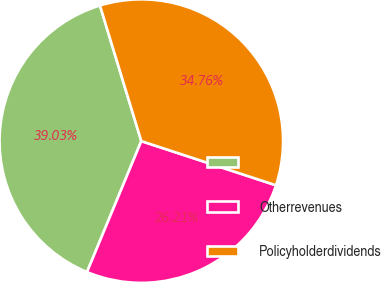<chart> <loc_0><loc_0><loc_500><loc_500><pie_chart><ecel><fcel>Otherrevenues<fcel>Policyholderdividends<nl><fcel>39.03%<fcel>26.21%<fcel>34.76%<nl></chart> 